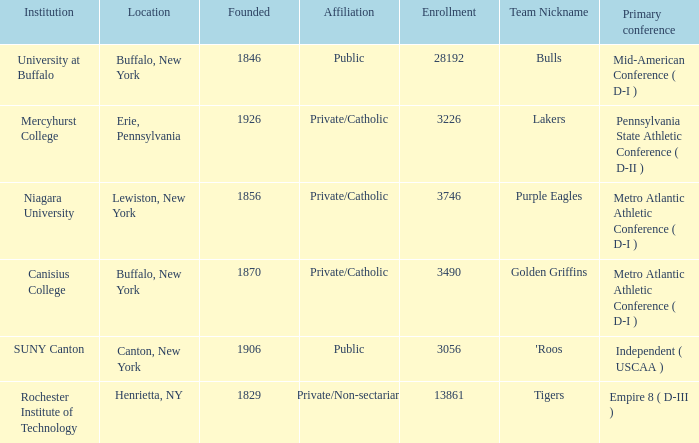What kind of school is Canton, New York? Public. 